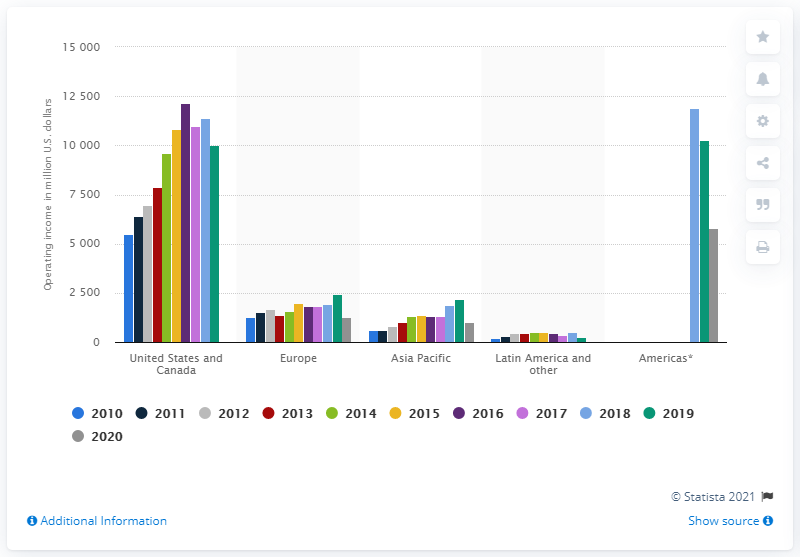Mention a couple of crucial points in this snapshot. According to the information provided, the Walt Disney Company's operating income in Europe accounted for a significant portion of the company's overall operating income in 1275. In 2020, Walt Disney's operating income from the Americas was $58,190,000 in dollars. 